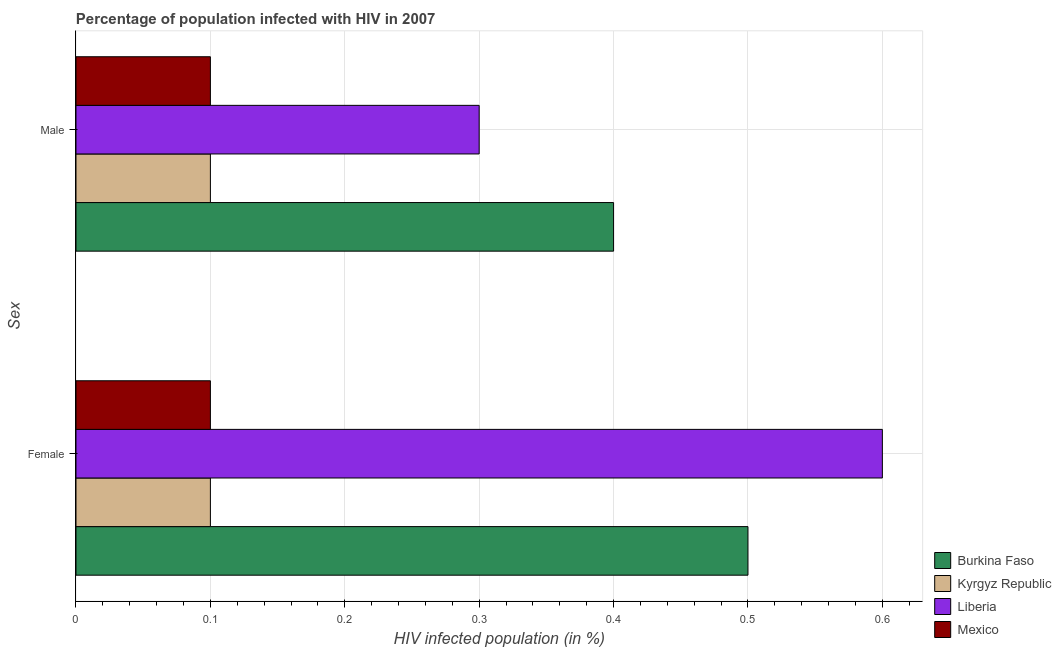How many groups of bars are there?
Your answer should be compact. 2. Are the number of bars on each tick of the Y-axis equal?
Keep it short and to the point. Yes. How many bars are there on the 2nd tick from the top?
Your answer should be very brief. 4. What is the percentage of males who are infected with hiv in Mexico?
Keep it short and to the point. 0.1. Across all countries, what is the maximum percentage of females who are infected with hiv?
Your answer should be compact. 0.6. In which country was the percentage of males who are infected with hiv maximum?
Provide a succinct answer. Burkina Faso. In which country was the percentage of males who are infected with hiv minimum?
Your response must be concise. Kyrgyz Republic. What is the total percentage of females who are infected with hiv in the graph?
Offer a terse response. 1.3. What is the difference between the percentage of females who are infected with hiv in Liberia and that in Burkina Faso?
Ensure brevity in your answer.  0.1. What is the difference between the percentage of males who are infected with hiv in Burkina Faso and the percentage of females who are infected with hiv in Kyrgyz Republic?
Provide a short and direct response. 0.3. What is the average percentage of females who are infected with hiv per country?
Provide a short and direct response. 0.33. In how many countries, is the percentage of females who are infected with hiv greater than 0.44 %?
Your response must be concise. 2. What is the ratio of the percentage of males who are infected with hiv in Kyrgyz Republic to that in Liberia?
Offer a very short reply. 0.33. Is the percentage of males who are infected with hiv in Burkina Faso less than that in Liberia?
Provide a succinct answer. No. What does the 3rd bar from the top in Female represents?
Provide a short and direct response. Kyrgyz Republic. What does the 1st bar from the bottom in Male represents?
Your answer should be very brief. Burkina Faso. Are all the bars in the graph horizontal?
Offer a terse response. Yes. What is the difference between two consecutive major ticks on the X-axis?
Provide a short and direct response. 0.1. Does the graph contain any zero values?
Make the answer very short. No. Where does the legend appear in the graph?
Your response must be concise. Bottom right. How many legend labels are there?
Make the answer very short. 4. What is the title of the graph?
Your response must be concise. Percentage of population infected with HIV in 2007. What is the label or title of the X-axis?
Your answer should be compact. HIV infected population (in %). What is the label or title of the Y-axis?
Ensure brevity in your answer.  Sex. What is the HIV infected population (in %) in Burkina Faso in Female?
Offer a very short reply. 0.5. What is the HIV infected population (in %) of Kyrgyz Republic in Female?
Offer a terse response. 0.1. What is the HIV infected population (in %) in Liberia in Female?
Your answer should be compact. 0.6. What is the HIV infected population (in %) of Mexico in Male?
Make the answer very short. 0.1. Across all Sex, what is the maximum HIV infected population (in %) of Burkina Faso?
Make the answer very short. 0.5. Across all Sex, what is the maximum HIV infected population (in %) in Kyrgyz Republic?
Give a very brief answer. 0.1. Across all Sex, what is the minimum HIV infected population (in %) in Burkina Faso?
Provide a short and direct response. 0.4. Across all Sex, what is the minimum HIV infected population (in %) in Liberia?
Ensure brevity in your answer.  0.3. Across all Sex, what is the minimum HIV infected population (in %) in Mexico?
Ensure brevity in your answer.  0.1. What is the total HIV infected population (in %) of Burkina Faso in the graph?
Keep it short and to the point. 0.9. What is the difference between the HIV infected population (in %) of Burkina Faso in Female and that in Male?
Give a very brief answer. 0.1. What is the difference between the HIV infected population (in %) in Mexico in Female and that in Male?
Ensure brevity in your answer.  0. What is the difference between the HIV infected population (in %) in Burkina Faso in Female and the HIV infected population (in %) in Kyrgyz Republic in Male?
Offer a very short reply. 0.4. What is the difference between the HIV infected population (in %) of Burkina Faso in Female and the HIV infected population (in %) of Liberia in Male?
Offer a very short reply. 0.2. What is the difference between the HIV infected population (in %) in Kyrgyz Republic in Female and the HIV infected population (in %) in Liberia in Male?
Your answer should be very brief. -0.2. What is the average HIV infected population (in %) in Burkina Faso per Sex?
Your answer should be very brief. 0.45. What is the average HIV infected population (in %) in Kyrgyz Republic per Sex?
Offer a terse response. 0.1. What is the average HIV infected population (in %) in Liberia per Sex?
Provide a succinct answer. 0.45. What is the difference between the HIV infected population (in %) in Burkina Faso and HIV infected population (in %) in Kyrgyz Republic in Female?
Provide a succinct answer. 0.4. What is the difference between the HIV infected population (in %) of Kyrgyz Republic and HIV infected population (in %) of Liberia in Female?
Ensure brevity in your answer.  -0.5. What is the difference between the HIV infected population (in %) of Kyrgyz Republic and HIV infected population (in %) of Mexico in Female?
Offer a terse response. 0. What is the difference between the HIV infected population (in %) of Burkina Faso and HIV infected population (in %) of Kyrgyz Republic in Male?
Provide a short and direct response. 0.3. What is the difference between the HIV infected population (in %) in Burkina Faso and HIV infected population (in %) in Liberia in Male?
Your answer should be very brief. 0.1. What is the difference between the HIV infected population (in %) in Burkina Faso and HIV infected population (in %) in Mexico in Male?
Offer a very short reply. 0.3. What is the difference between the HIV infected population (in %) of Kyrgyz Republic and HIV infected population (in %) of Liberia in Male?
Ensure brevity in your answer.  -0.2. What is the ratio of the HIV infected population (in %) of Burkina Faso in Female to that in Male?
Your answer should be compact. 1.25. What is the ratio of the HIV infected population (in %) in Kyrgyz Republic in Female to that in Male?
Provide a short and direct response. 1. What is the ratio of the HIV infected population (in %) in Liberia in Female to that in Male?
Your answer should be compact. 2. What is the ratio of the HIV infected population (in %) in Mexico in Female to that in Male?
Ensure brevity in your answer.  1. What is the difference between the highest and the second highest HIV infected population (in %) in Mexico?
Your answer should be compact. 0. What is the difference between the highest and the lowest HIV infected population (in %) in Kyrgyz Republic?
Make the answer very short. 0. What is the difference between the highest and the lowest HIV infected population (in %) in Liberia?
Ensure brevity in your answer.  0.3. 